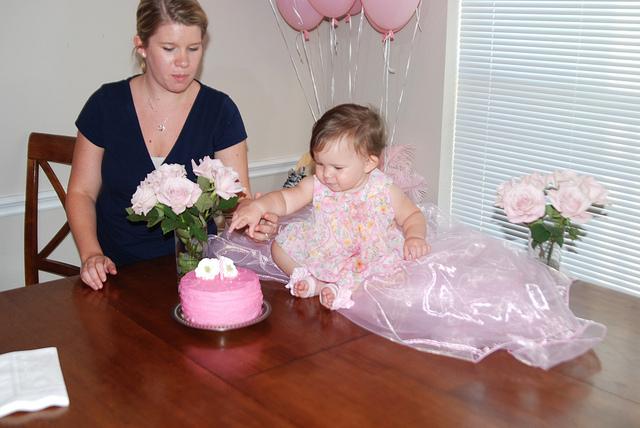What color is the cake?
Be succinct. Pink. Where is the baby sitting?
Write a very short answer. Table. Which hand is the mother using to touch the baby?
Keep it brief. Left. Whose birthday is it?
Concise answer only. Baby. Does the dress have lace on it?
Write a very short answer. No. What occasion is being celebrated?
Give a very brief answer. Birthday. 